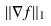<formula> <loc_0><loc_0><loc_500><loc_500>\| \nabla f \| _ { 1 }</formula> 